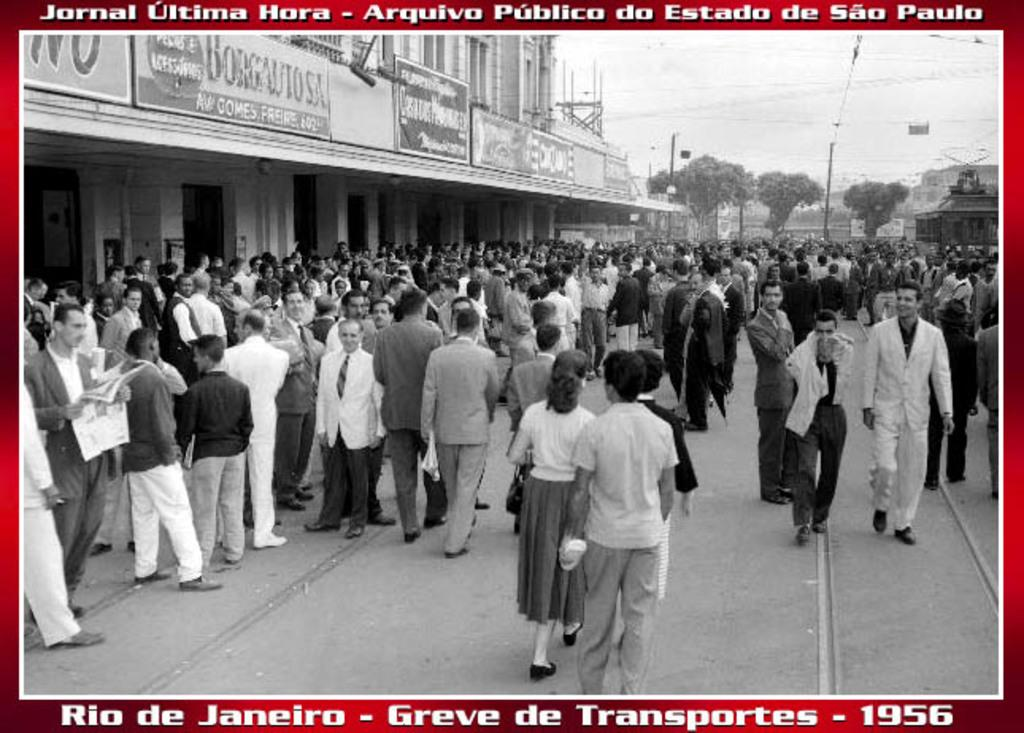<image>
Relay a brief, clear account of the picture shown. A 1956 black and white photo is bordered in red and is of Rio de Janeiro titled 'Greve de Transportes. 